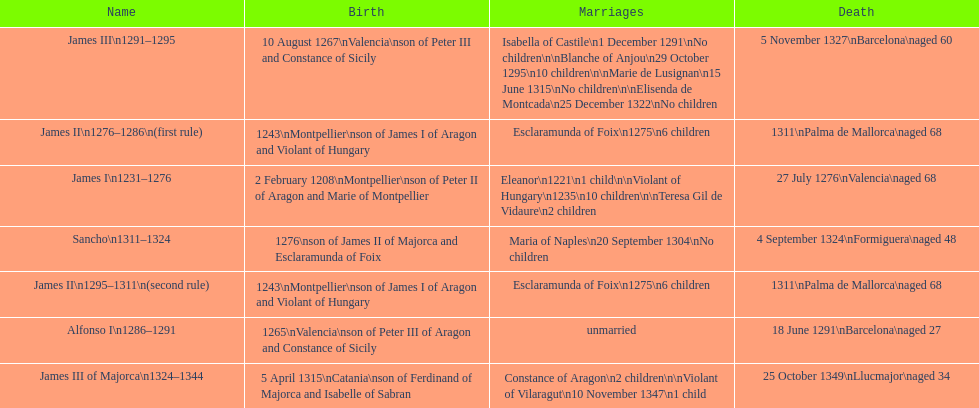How long was james ii in power, including his second rule? 26 years. 